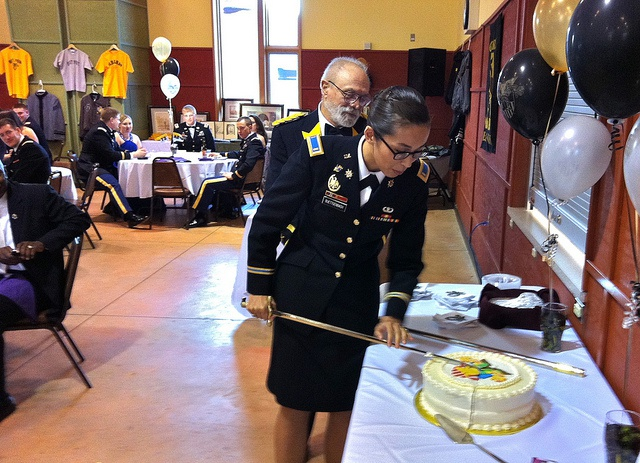Describe the objects in this image and their specific colors. I can see people in tan, black, maroon, brown, and gray tones, dining table in tan, lavender, and gray tones, people in tan, black, navy, lavender, and maroon tones, cake in tan, beige, and darkgray tones, and people in tan, black, gray, and darkgray tones in this image. 